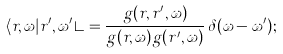Convert formula to latex. <formula><loc_0><loc_0><loc_500><loc_500>\langle r , \omega | r ^ { \prime } , \omega ^ { \prime } \rangle = \frac { g ( r , r ^ { \prime } , \omega ) } { g ( r , \omega ) g ( r ^ { \prime } , \omega ) } \, \delta ( \omega - \omega ^ { \prime } ) ;</formula> 